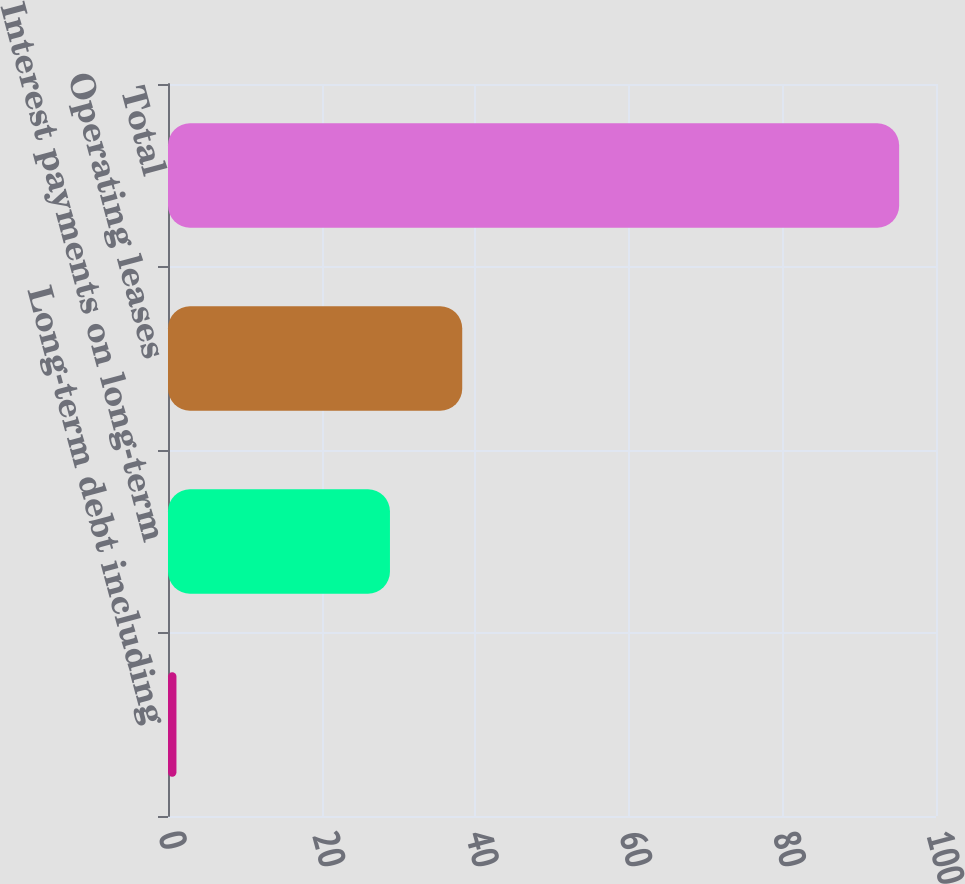Convert chart. <chart><loc_0><loc_0><loc_500><loc_500><bar_chart><fcel>Long-term debt including<fcel>Interest payments on long-term<fcel>Operating leases<fcel>Total<nl><fcel>1.1<fcel>28.9<fcel>38.31<fcel>95.2<nl></chart> 